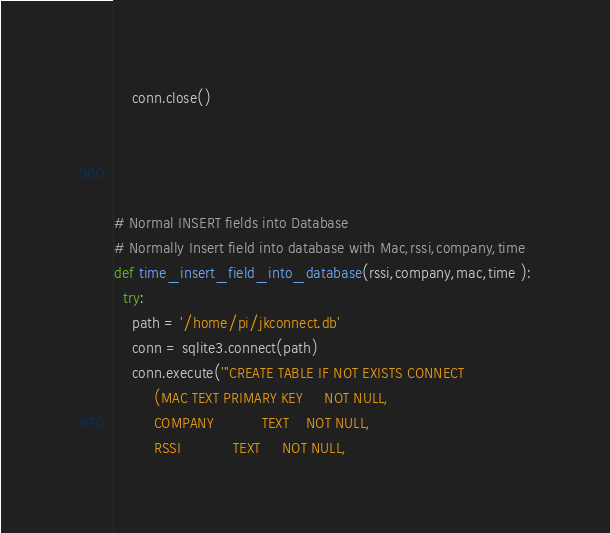<code> <loc_0><loc_0><loc_500><loc_500><_Python_>    conn.close()




# Normal INSERT fields into Database
# Normally Insert field into database with Mac,rssi,company,time
def time_insert_field_into_database(rssi,company,mac,time ):
  try:
    path = '/home/pi/jkconnect.db'
    conn = sqlite3.connect(path)
    conn.execute('''CREATE TABLE IF NOT EXISTS CONNECT
         (MAC TEXT PRIMARY KEY     NOT NULL,
         COMPANY           TEXT    NOT NULL,
         RSSI            TEXT     NOT NULL,</code> 